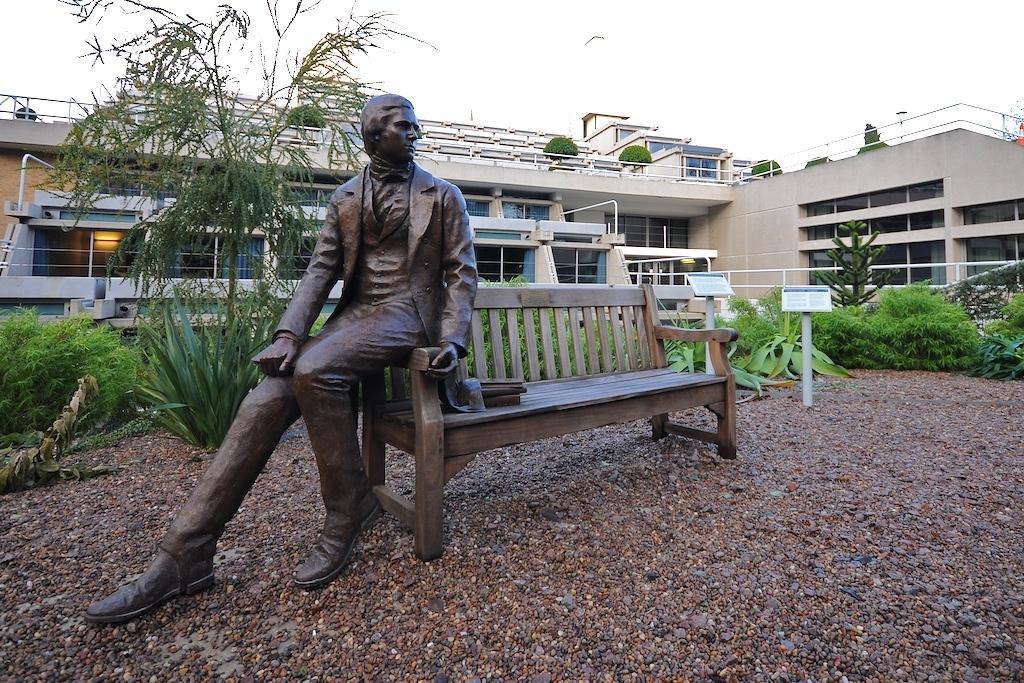How would you summarize this image in a sentence or two? In the middle there is a bench. On the left there is a statue of man. In the background there is a house ,plants ,board ,sky and bird. 